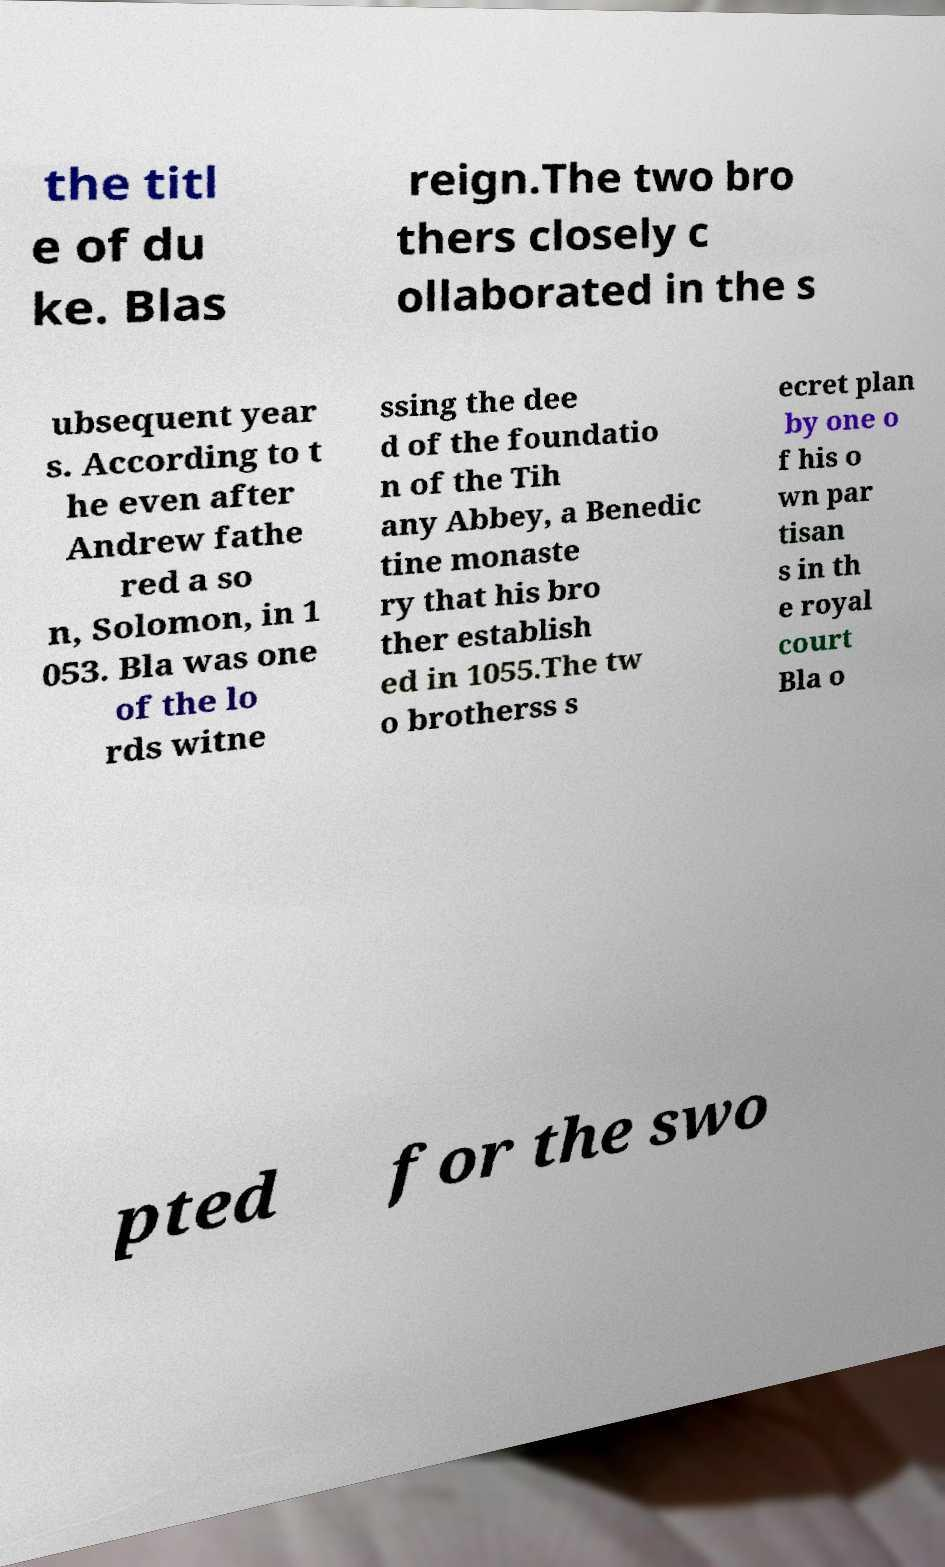I need the written content from this picture converted into text. Can you do that? the titl e of du ke. Blas reign.The two bro thers closely c ollaborated in the s ubsequent year s. According to t he even after Andrew fathe red a so n, Solomon, in 1 053. Bla was one of the lo rds witne ssing the dee d of the foundatio n of the Tih any Abbey, a Benedic tine monaste ry that his bro ther establish ed in 1055.The tw o brotherss s ecret plan by one o f his o wn par tisan s in th e royal court Bla o pted for the swo 